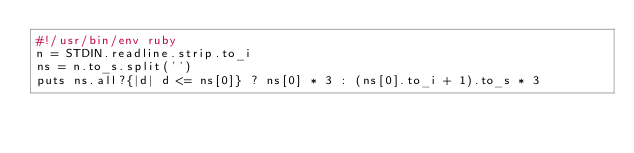Convert code to text. <code><loc_0><loc_0><loc_500><loc_500><_Ruby_>#!/usr/bin/env ruby
n = STDIN.readline.strip.to_i
ns = n.to_s.split('')
puts ns.all?{|d| d <= ns[0]} ? ns[0] * 3 : (ns[0].to_i + 1).to_s * 3
</code> 